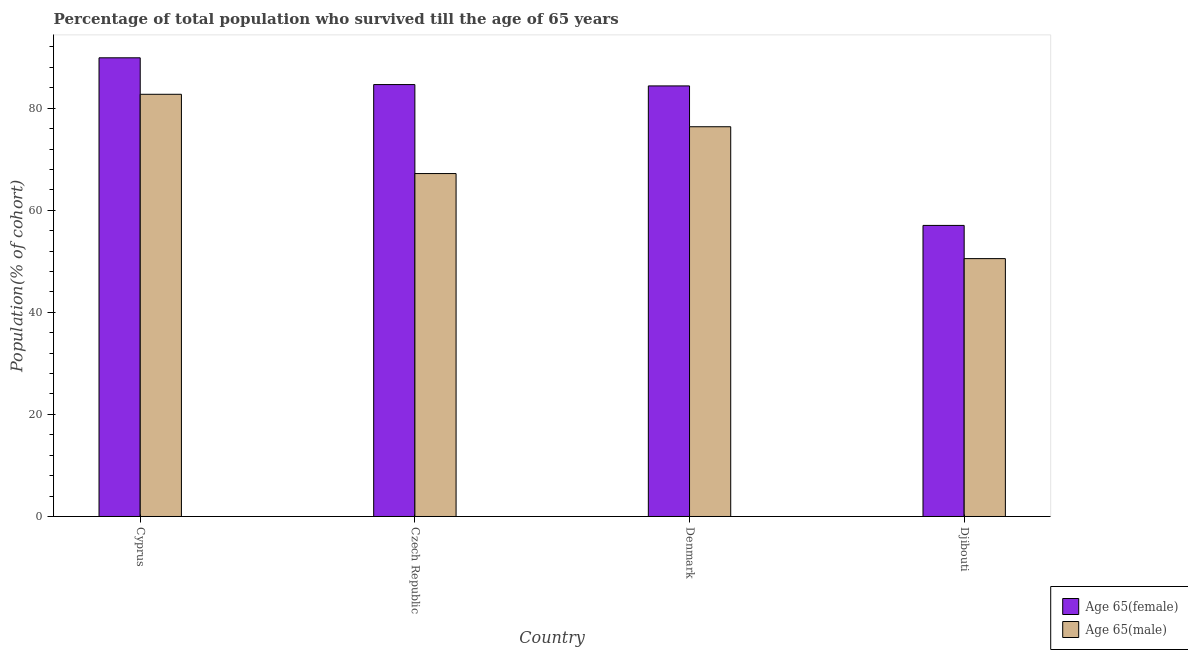Are the number of bars on each tick of the X-axis equal?
Your answer should be very brief. Yes. How many bars are there on the 1st tick from the left?
Ensure brevity in your answer.  2. How many bars are there on the 4th tick from the right?
Provide a short and direct response. 2. In how many cases, is the number of bars for a given country not equal to the number of legend labels?
Your answer should be compact. 0. What is the percentage of female population who survived till age of 65 in Djibouti?
Ensure brevity in your answer.  57.03. Across all countries, what is the maximum percentage of female population who survived till age of 65?
Your answer should be compact. 89.87. Across all countries, what is the minimum percentage of female population who survived till age of 65?
Offer a terse response. 57.03. In which country was the percentage of male population who survived till age of 65 maximum?
Your response must be concise. Cyprus. In which country was the percentage of male population who survived till age of 65 minimum?
Your response must be concise. Djibouti. What is the total percentage of male population who survived till age of 65 in the graph?
Provide a short and direct response. 276.81. What is the difference between the percentage of female population who survived till age of 65 in Cyprus and that in Denmark?
Provide a short and direct response. 5.51. What is the difference between the percentage of female population who survived till age of 65 in Denmark and the percentage of male population who survived till age of 65 in Djibouti?
Offer a very short reply. 33.84. What is the average percentage of female population who survived till age of 65 per country?
Keep it short and to the point. 78.97. What is the difference between the percentage of male population who survived till age of 65 and percentage of female population who survived till age of 65 in Czech Republic?
Offer a very short reply. -17.44. In how many countries, is the percentage of male population who survived till age of 65 greater than 56 %?
Ensure brevity in your answer.  3. What is the ratio of the percentage of female population who survived till age of 65 in Czech Republic to that in Denmark?
Your response must be concise. 1. Is the percentage of female population who survived till age of 65 in Cyprus less than that in Czech Republic?
Offer a very short reply. No. What is the difference between the highest and the second highest percentage of female population who survived till age of 65?
Give a very brief answer. 5.24. What is the difference between the highest and the lowest percentage of male population who survived till age of 65?
Ensure brevity in your answer.  32.2. In how many countries, is the percentage of male population who survived till age of 65 greater than the average percentage of male population who survived till age of 65 taken over all countries?
Provide a succinct answer. 2. Is the sum of the percentage of female population who survived till age of 65 in Cyprus and Czech Republic greater than the maximum percentage of male population who survived till age of 65 across all countries?
Your answer should be compact. Yes. What does the 2nd bar from the left in Cyprus represents?
Provide a short and direct response. Age 65(male). What does the 2nd bar from the right in Djibouti represents?
Provide a short and direct response. Age 65(female). How many bars are there?
Your answer should be compact. 8. Are all the bars in the graph horizontal?
Offer a very short reply. No. How many countries are there in the graph?
Keep it short and to the point. 4. Are the values on the major ticks of Y-axis written in scientific E-notation?
Offer a very short reply. No. How are the legend labels stacked?
Offer a terse response. Vertical. What is the title of the graph?
Offer a very short reply. Percentage of total population who survived till the age of 65 years. Does "Transport services" appear as one of the legend labels in the graph?
Keep it short and to the point. No. What is the label or title of the X-axis?
Your answer should be compact. Country. What is the label or title of the Y-axis?
Your response must be concise. Population(% of cohort). What is the Population(% of cohort) of Age 65(female) in Cyprus?
Give a very brief answer. 89.87. What is the Population(% of cohort) of Age 65(male) in Cyprus?
Your response must be concise. 82.72. What is the Population(% of cohort) in Age 65(female) in Czech Republic?
Provide a succinct answer. 84.63. What is the Population(% of cohort) in Age 65(male) in Czech Republic?
Make the answer very short. 67.19. What is the Population(% of cohort) in Age 65(female) in Denmark?
Your answer should be very brief. 84.36. What is the Population(% of cohort) of Age 65(male) in Denmark?
Provide a short and direct response. 76.36. What is the Population(% of cohort) of Age 65(female) in Djibouti?
Your answer should be very brief. 57.03. What is the Population(% of cohort) in Age 65(male) in Djibouti?
Your answer should be compact. 50.53. Across all countries, what is the maximum Population(% of cohort) in Age 65(female)?
Ensure brevity in your answer.  89.87. Across all countries, what is the maximum Population(% of cohort) of Age 65(male)?
Provide a short and direct response. 82.72. Across all countries, what is the minimum Population(% of cohort) of Age 65(female)?
Your answer should be very brief. 57.03. Across all countries, what is the minimum Population(% of cohort) in Age 65(male)?
Offer a terse response. 50.53. What is the total Population(% of cohort) of Age 65(female) in the graph?
Offer a very short reply. 315.9. What is the total Population(% of cohort) of Age 65(male) in the graph?
Keep it short and to the point. 276.81. What is the difference between the Population(% of cohort) in Age 65(female) in Cyprus and that in Czech Republic?
Provide a succinct answer. 5.24. What is the difference between the Population(% of cohort) in Age 65(male) in Cyprus and that in Czech Republic?
Your response must be concise. 15.53. What is the difference between the Population(% of cohort) of Age 65(female) in Cyprus and that in Denmark?
Keep it short and to the point. 5.51. What is the difference between the Population(% of cohort) in Age 65(male) in Cyprus and that in Denmark?
Your answer should be compact. 6.36. What is the difference between the Population(% of cohort) in Age 65(female) in Cyprus and that in Djibouti?
Ensure brevity in your answer.  32.84. What is the difference between the Population(% of cohort) of Age 65(male) in Cyprus and that in Djibouti?
Provide a succinct answer. 32.2. What is the difference between the Population(% of cohort) of Age 65(female) in Czech Republic and that in Denmark?
Your answer should be very brief. 0.26. What is the difference between the Population(% of cohort) of Age 65(male) in Czech Republic and that in Denmark?
Your answer should be very brief. -9.17. What is the difference between the Population(% of cohort) in Age 65(female) in Czech Republic and that in Djibouti?
Ensure brevity in your answer.  27.6. What is the difference between the Population(% of cohort) in Age 65(male) in Czech Republic and that in Djibouti?
Provide a short and direct response. 16.67. What is the difference between the Population(% of cohort) of Age 65(female) in Denmark and that in Djibouti?
Your response must be concise. 27.33. What is the difference between the Population(% of cohort) of Age 65(male) in Denmark and that in Djibouti?
Offer a very short reply. 25.84. What is the difference between the Population(% of cohort) of Age 65(female) in Cyprus and the Population(% of cohort) of Age 65(male) in Czech Republic?
Your response must be concise. 22.68. What is the difference between the Population(% of cohort) in Age 65(female) in Cyprus and the Population(% of cohort) in Age 65(male) in Denmark?
Ensure brevity in your answer.  13.51. What is the difference between the Population(% of cohort) of Age 65(female) in Cyprus and the Population(% of cohort) of Age 65(male) in Djibouti?
Give a very brief answer. 39.34. What is the difference between the Population(% of cohort) in Age 65(female) in Czech Republic and the Population(% of cohort) in Age 65(male) in Denmark?
Offer a terse response. 8.26. What is the difference between the Population(% of cohort) of Age 65(female) in Czech Republic and the Population(% of cohort) of Age 65(male) in Djibouti?
Keep it short and to the point. 34.1. What is the difference between the Population(% of cohort) of Age 65(female) in Denmark and the Population(% of cohort) of Age 65(male) in Djibouti?
Your answer should be compact. 33.84. What is the average Population(% of cohort) of Age 65(female) per country?
Give a very brief answer. 78.97. What is the average Population(% of cohort) of Age 65(male) per country?
Make the answer very short. 69.2. What is the difference between the Population(% of cohort) in Age 65(female) and Population(% of cohort) in Age 65(male) in Cyprus?
Your response must be concise. 7.15. What is the difference between the Population(% of cohort) of Age 65(female) and Population(% of cohort) of Age 65(male) in Czech Republic?
Offer a very short reply. 17.44. What is the difference between the Population(% of cohort) of Age 65(female) and Population(% of cohort) of Age 65(male) in Denmark?
Offer a very short reply. 8. What is the difference between the Population(% of cohort) of Age 65(female) and Population(% of cohort) of Age 65(male) in Djibouti?
Offer a terse response. 6.51. What is the ratio of the Population(% of cohort) in Age 65(female) in Cyprus to that in Czech Republic?
Your response must be concise. 1.06. What is the ratio of the Population(% of cohort) in Age 65(male) in Cyprus to that in Czech Republic?
Offer a terse response. 1.23. What is the ratio of the Population(% of cohort) in Age 65(female) in Cyprus to that in Denmark?
Offer a very short reply. 1.07. What is the ratio of the Population(% of cohort) of Age 65(male) in Cyprus to that in Denmark?
Give a very brief answer. 1.08. What is the ratio of the Population(% of cohort) in Age 65(female) in Cyprus to that in Djibouti?
Offer a very short reply. 1.58. What is the ratio of the Population(% of cohort) in Age 65(male) in Cyprus to that in Djibouti?
Your response must be concise. 1.64. What is the ratio of the Population(% of cohort) in Age 65(female) in Czech Republic to that in Denmark?
Offer a very short reply. 1. What is the ratio of the Population(% of cohort) of Age 65(male) in Czech Republic to that in Denmark?
Provide a succinct answer. 0.88. What is the ratio of the Population(% of cohort) in Age 65(female) in Czech Republic to that in Djibouti?
Your answer should be very brief. 1.48. What is the ratio of the Population(% of cohort) of Age 65(male) in Czech Republic to that in Djibouti?
Provide a succinct answer. 1.33. What is the ratio of the Population(% of cohort) in Age 65(female) in Denmark to that in Djibouti?
Offer a terse response. 1.48. What is the ratio of the Population(% of cohort) of Age 65(male) in Denmark to that in Djibouti?
Keep it short and to the point. 1.51. What is the difference between the highest and the second highest Population(% of cohort) of Age 65(female)?
Your answer should be very brief. 5.24. What is the difference between the highest and the second highest Population(% of cohort) of Age 65(male)?
Your response must be concise. 6.36. What is the difference between the highest and the lowest Population(% of cohort) of Age 65(female)?
Your answer should be compact. 32.84. What is the difference between the highest and the lowest Population(% of cohort) in Age 65(male)?
Make the answer very short. 32.2. 